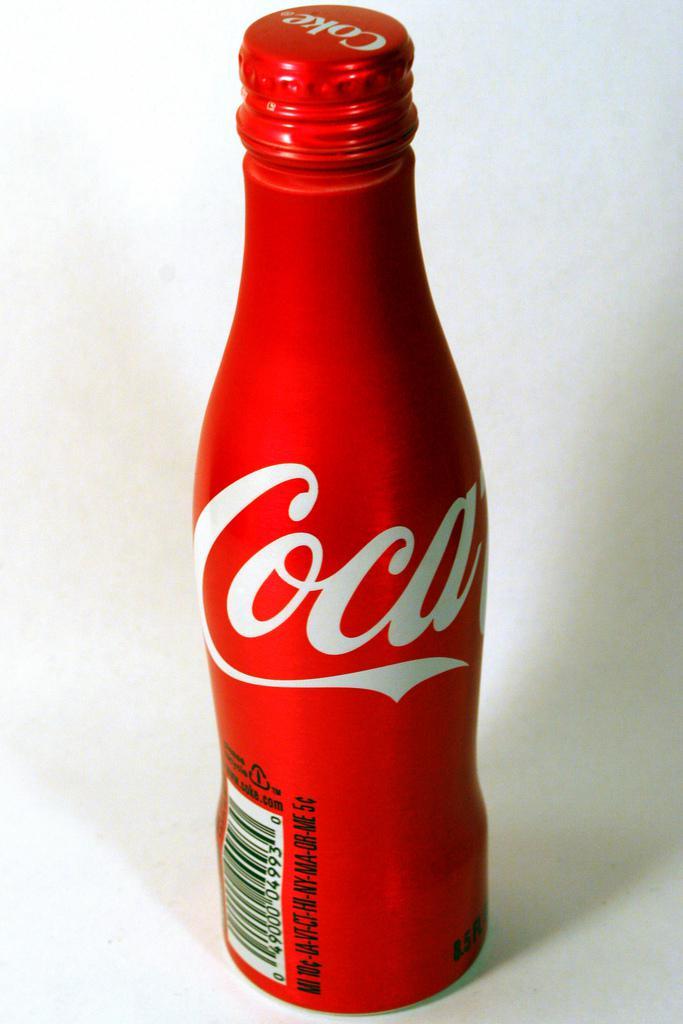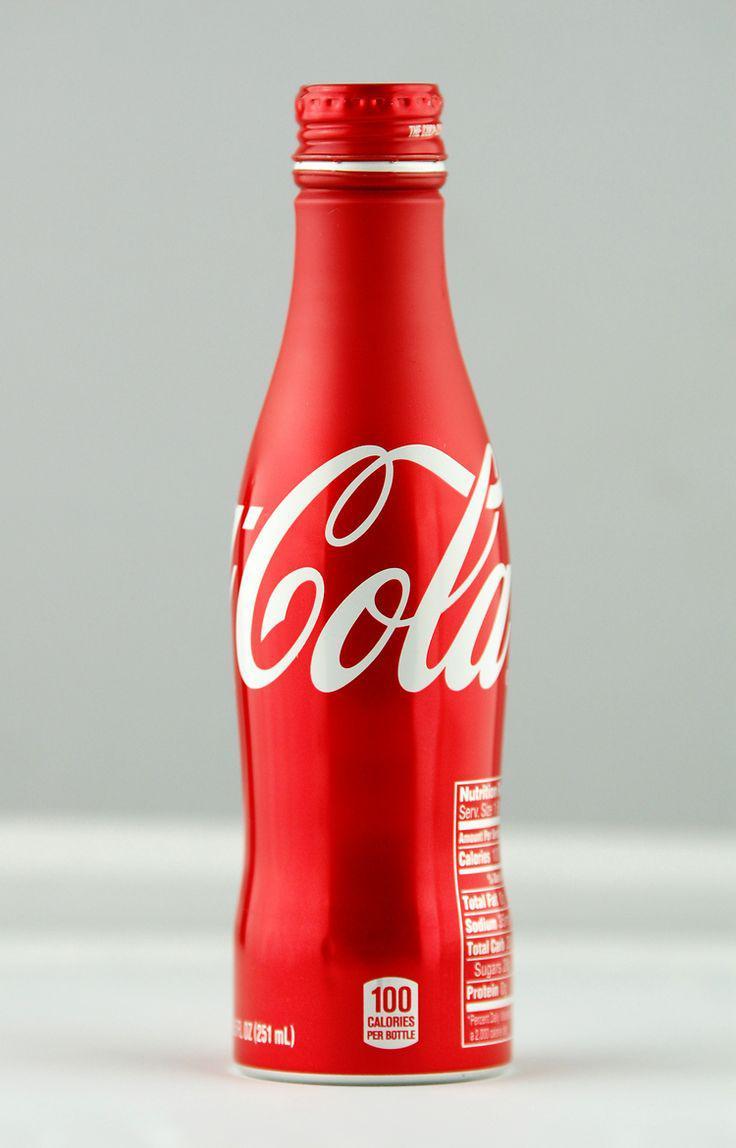The first image is the image on the left, the second image is the image on the right. Given the left and right images, does the statement "Some of the beverages are sugar free." hold true? Answer yes or no. No. The first image is the image on the left, the second image is the image on the right. For the images shown, is this caption "Each image includes at least one bottle that is bright red with writing in white script letters around its middle." true? Answer yes or no. Yes. 